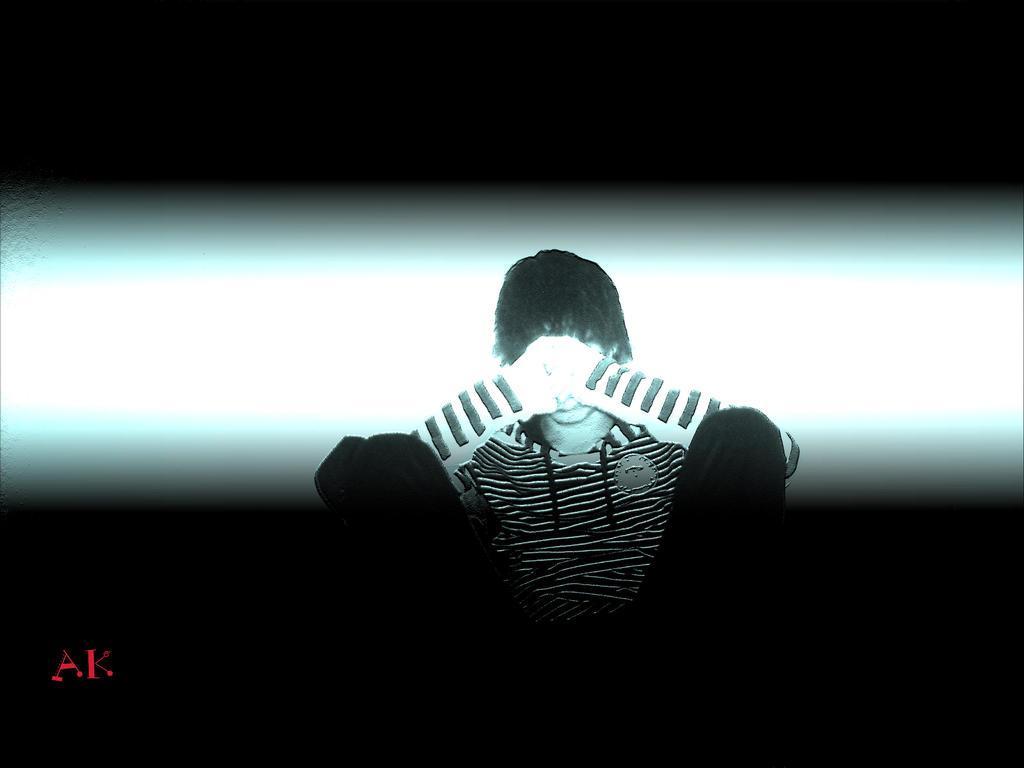How would you summarize this image in a sentence or two? In this image there is a person sitting, behind the person there is a wall, on the person there is light falling, at the bottom of the image there is some text. 